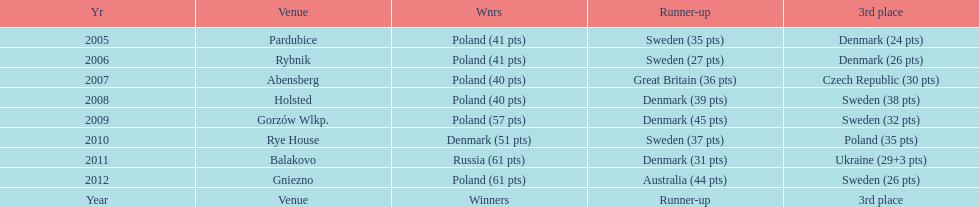What is the total number of points earned in the years 2009? 134. 